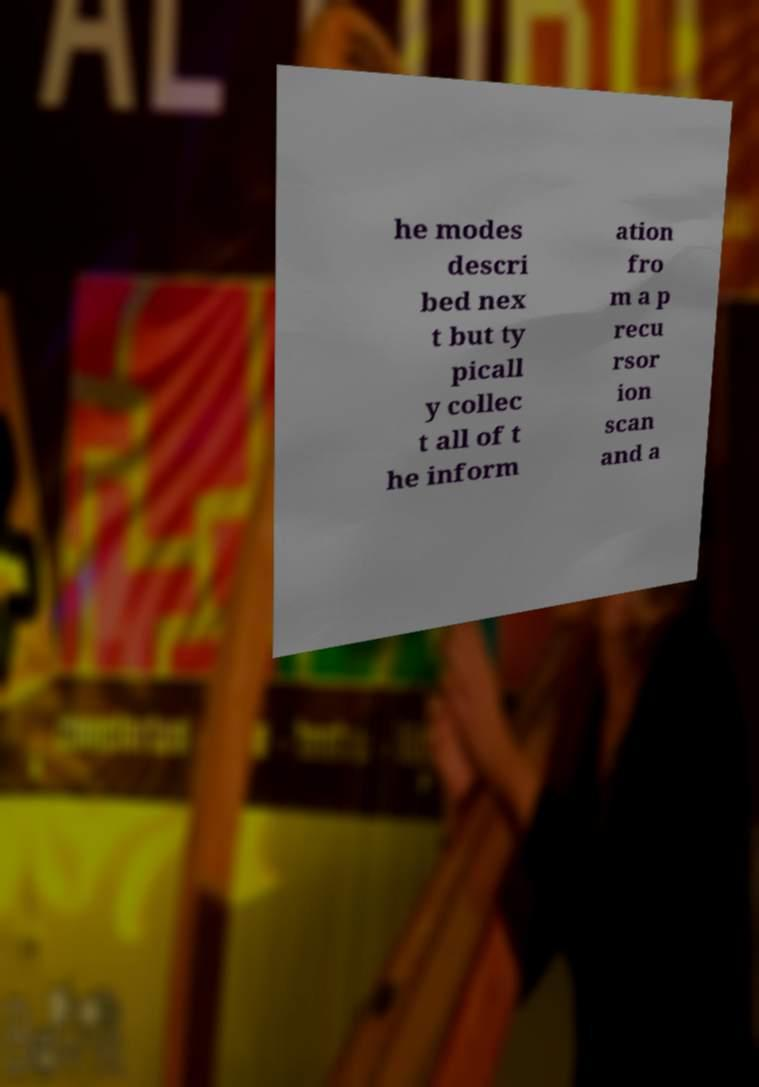For documentation purposes, I need the text within this image transcribed. Could you provide that? he modes descri bed nex t but ty picall y collec t all of t he inform ation fro m a p recu rsor ion scan and a 